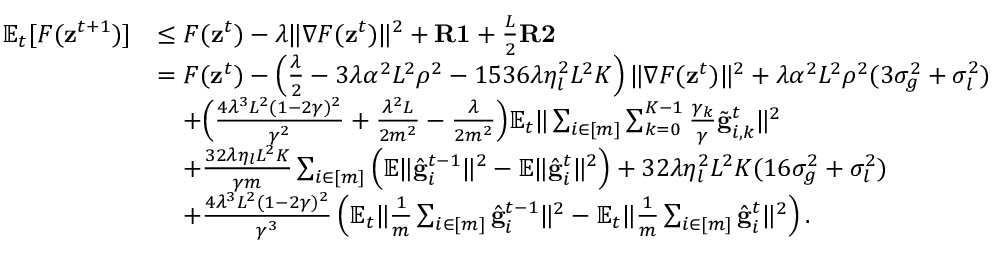Convert formula to latex. <formula><loc_0><loc_0><loc_500><loc_500>\begin{array} { r l } { \mathbb { E } _ { t } [ F ( z ^ { t + 1 } ) ] } & { \leq F ( z ^ { t } ) - \lambda \| \nabla F ( z ^ { t } ) \| ^ { 2 } + R 1 + \frac { L } { 2 } R 2 } \\ & { = F ( z ^ { t } ) - \left ( \frac { \lambda } { 2 } - 3 \lambda \alpha ^ { 2 } L ^ { 2 } \rho ^ { 2 } - 1 5 3 6 \lambda \eta _ { l } ^ { 2 } L ^ { 2 } K \right ) \| \nabla F ( z ^ { t } ) \| ^ { 2 } + \lambda \alpha ^ { 2 } L ^ { 2 } \rho ^ { 2 } ( 3 \sigma _ { g } ^ { 2 } + \sigma _ { l } ^ { 2 } ) } \\ & { \quad + \left ( \frac { 4 \lambda ^ { 3 } L ^ { 2 } ( 1 - 2 \gamma ) ^ { 2 } } { \gamma ^ { 2 } } + \frac { \lambda ^ { 2 } L } { 2 m ^ { 2 } } - \frac { \lambda } { 2 m ^ { 2 } } \right ) \mathbb { E } _ { t } \| \sum _ { i \in [ m ] } \sum _ { k = 0 } ^ { K - 1 } \frac { \gamma _ { k } } { \gamma } \tilde { g } _ { i , k } ^ { t } \| ^ { 2 } } \\ & { \quad + \frac { 3 2 \lambda \eta _ { l } L ^ { 2 } K } { \gamma m } \sum _ { i \in [ m ] } \left ( \mathbb { E } \| \hat { g } _ { i } ^ { t - 1 } \| ^ { 2 } - \mathbb { E } \| \hat { g } _ { i } ^ { t } \| ^ { 2 } \right ) + 3 2 \lambda \eta _ { l } ^ { 2 } L ^ { 2 } K ( 1 6 \sigma _ { g } ^ { 2 } + \sigma _ { l } ^ { 2 } ) } \\ & { \quad + \frac { 4 \lambda ^ { 3 } L ^ { 2 } ( 1 - 2 \gamma ) ^ { 2 } } { \gamma ^ { 3 } } \left ( \mathbb { E } _ { t } \| \frac { 1 } { m } \sum _ { i \in [ m ] } \hat { g } _ { i } ^ { t - 1 } \| ^ { 2 } - \mathbb { E } _ { t } \| \frac { 1 } { m } \sum _ { i \in [ m ] } \hat { g } _ { i } ^ { t } \| ^ { 2 } \right ) . } \end{array}</formula> 